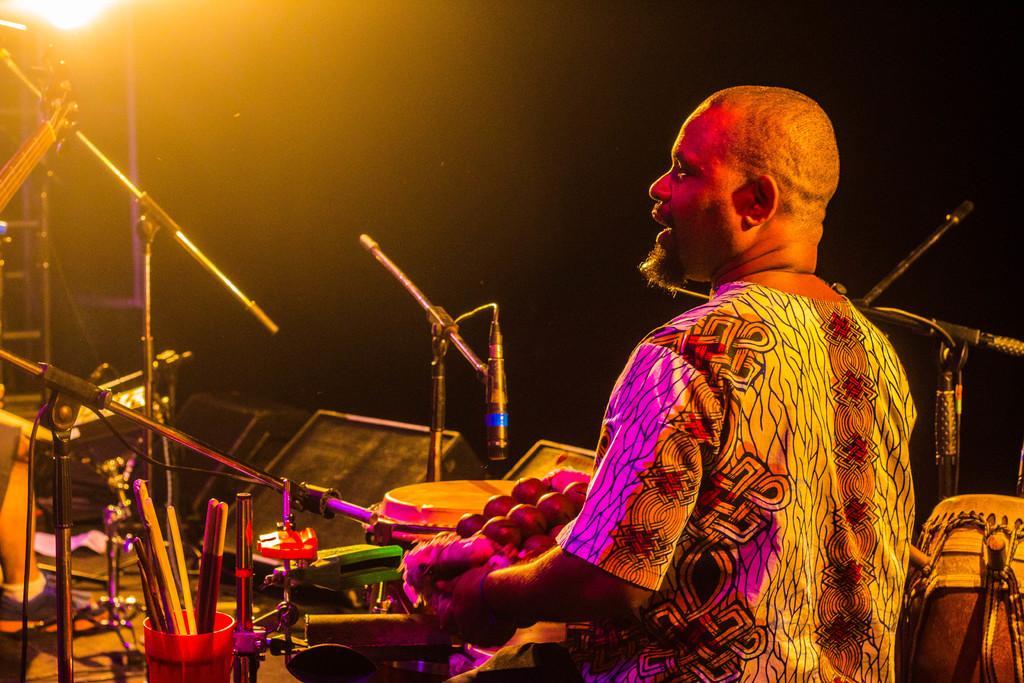Can you describe this image briefly? In this image I can see a man is standing. In front of him there is a box, stands and some musical instruments are placed. On the right side of the image I can see a drum. 